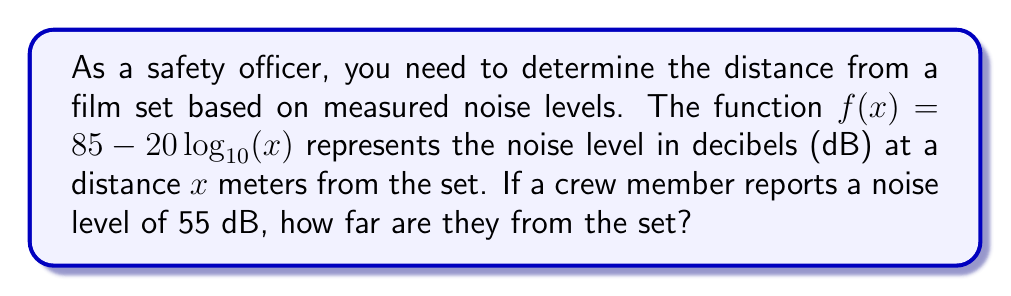Help me with this question. To solve this problem, we need to find the inverse function of $f(x)$ and then evaluate it for the given noise level.

1) First, let's express the inverse function:
   Let $y = f(x) = 85 - 20\log_{10}(x)$

2) To find the inverse, we swap $x$ and $y$:
   $x = 85 - 20\log_{10}(y)$

3) Now, let's solve for $y$:
   $x - 85 = -20\log_{10}(y)$
   $\frac{85-x}{20} = \log_{10}(y)$

4) Apply $10^x$ to both sides:
   $10^{\frac{85-x}{20}} = y$

5) Therefore, the inverse function is:
   $f^{-1}(x) = 10^{\frac{85-x}{20}}$

6) Now, we can evaluate this for the given noise level of 55 dB:
   $f^{-1}(55) = 10^{\frac{85-55}{20}} = 10^{\frac{30}{20}} = 10^{1.5}$

7) Calculate the final result:
   $10^{1.5} \approx 31.62$ meters
Answer: The crew member is approximately 31.62 meters from the film set. 